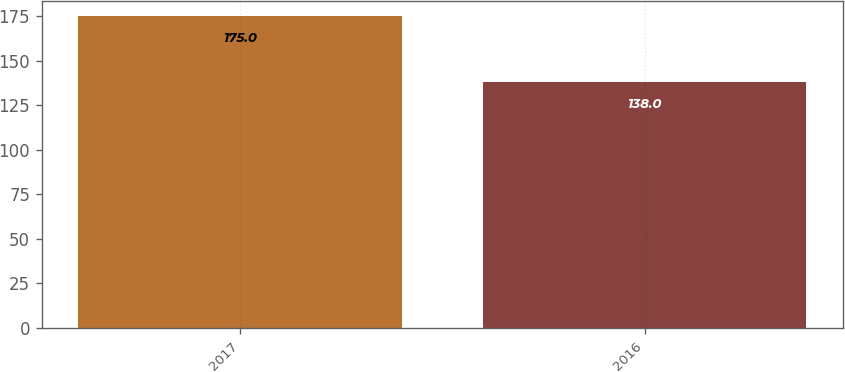Convert chart to OTSL. <chart><loc_0><loc_0><loc_500><loc_500><bar_chart><fcel>2017<fcel>2016<nl><fcel>175<fcel>138<nl></chart> 